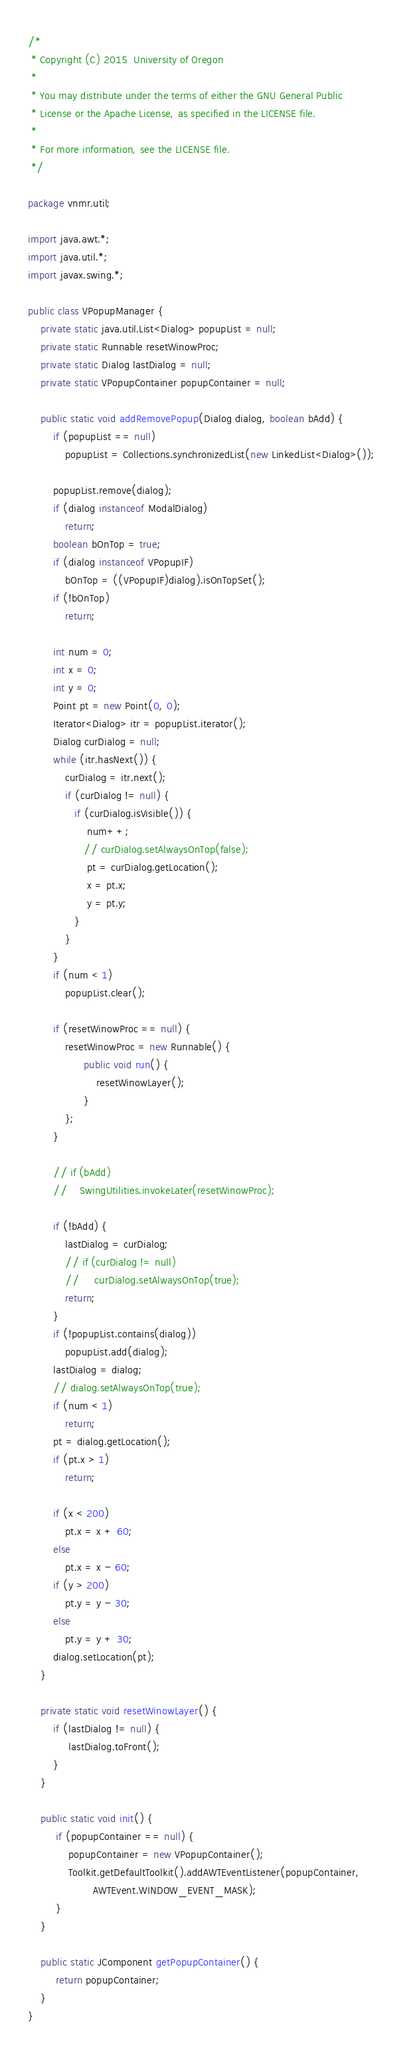Convert code to text. <code><loc_0><loc_0><loc_500><loc_500><_Java_>/*
 * Copyright (C) 2015  University of Oregon
 *
 * You may distribute under the terms of either the GNU General Public
 * License or the Apache License, as specified in the LICENSE file.
 *
 * For more information, see the LICENSE file.
 */

package vnmr.util;

import java.awt.*;
import java.util.*;
import javax.swing.*;

public class VPopupManager {
    private static java.util.List<Dialog> popupList = null;
    private static Runnable resetWinowProc;
    private static Dialog lastDialog = null;
    private static VPopupContainer popupContainer = null;

    public static void addRemovePopup(Dialog dialog, boolean bAdd) {
        if (popupList == null)
            popupList = Collections.synchronizedList(new LinkedList<Dialog>());

        popupList.remove(dialog);
        if (dialog instanceof ModalDialog)
            return;
        boolean bOnTop = true;
        if (dialog instanceof VPopupIF)
            bOnTop = ((VPopupIF)dialog).isOnTopSet();
        if (!bOnTop)
            return;

        int num = 0;
        int x = 0;
        int y = 0;
        Point pt = new Point(0, 0);
        Iterator<Dialog> itr = popupList.iterator();
        Dialog curDialog = null;
        while (itr.hasNext()) {
            curDialog = itr.next();
            if (curDialog != null) {
               if (curDialog.isVisible()) {
                   num++;
                  // curDialog.setAlwaysOnTop(false);
                   pt = curDialog.getLocation();
                   x = pt.x;
                   y = pt.y;
               }
            }
        }
        if (num < 1)
            popupList.clear();

        if (resetWinowProc == null) {
            resetWinowProc = new Runnable() {
                  public void run() {
                      resetWinowLayer();
                  }
            };
        }

        // if (bAdd)
        //    SwingUtilities.invokeLater(resetWinowProc);

        if (!bAdd) {
            lastDialog = curDialog;
            // if (curDialog != null)
            //     curDialog.setAlwaysOnTop(true);
            return;
        }
        if (!popupList.contains(dialog))
            popupList.add(dialog);
        lastDialog = dialog;
        // dialog.setAlwaysOnTop(true);
        if (num < 1)
            return;
        pt = dialog.getLocation();
        if (pt.x > 1)
            return;

        if (x < 200)
            pt.x = x + 60;
        else
            pt.x = x - 60;
        if (y > 200)
            pt.y = y - 30;
        else
            pt.y = y + 30;
        dialog.setLocation(pt);
    }

    private static void resetWinowLayer() {
        if (lastDialog != null) {
             lastDialog.toFront();
        }
    }

    public static void init() {
         if (popupContainer == null) {
             popupContainer = new VPopupContainer(); 
             Toolkit.getDefaultToolkit().addAWTEventListener(popupContainer,
                     AWTEvent.WINDOW_EVENT_MASK);
         }
    }

    public static JComponent getPopupContainer() {
         return popupContainer;
    }
}
</code> 